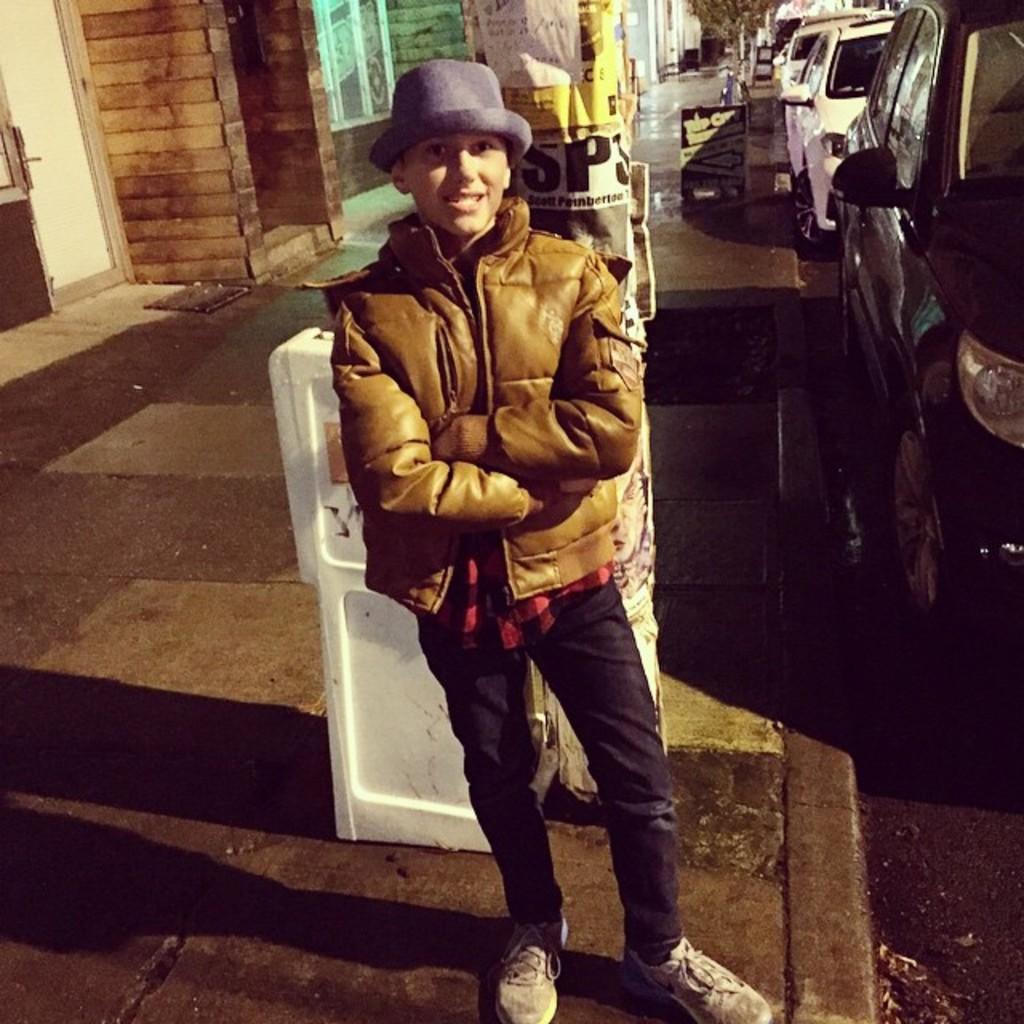Could you give a brief overview of what you see in this image? In this image a boy is standing wearing jacket and hat. On the road there are many vehicles. In the background there is building. 